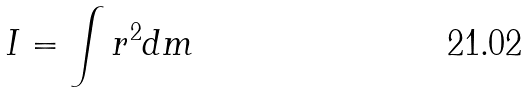<formula> <loc_0><loc_0><loc_500><loc_500>I = \int r ^ { 2 } d m</formula> 